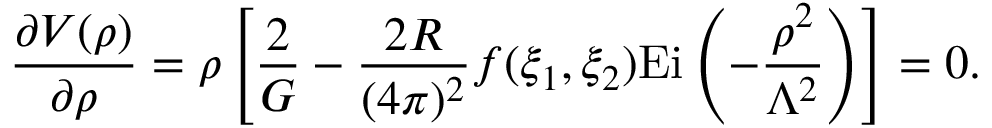<formula> <loc_0><loc_0><loc_500><loc_500>\frac { \partial V ( \rho ) } { \partial \rho } = \rho \left [ \frac { 2 } { G } - \frac { 2 R } { ( 4 \pi ) ^ { 2 } } f ( \xi _ { 1 } , \xi _ { 2 } ) E i \left ( - \frac { \rho ^ { 2 } } { \Lambda ^ { 2 } } \right ) \right ] = 0 .</formula> 